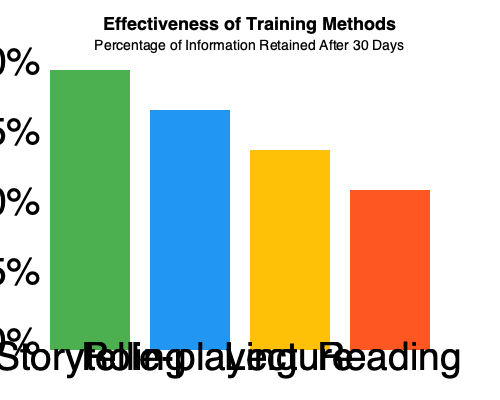Based on the bar graph comparing the effectiveness of various training methods, what is the difference in percentage points between the most effective and least effective methods, and which methods are they respectively? To answer this question, we need to follow these steps:

1. Identify the most effective method:
   - Storytelling has the highest bar, reaching about 90% retention.

2. Identify the least effective method:
   - Reading has the lowest bar, reaching about 45% retention.

3. Calculate the difference in percentage points:
   - Most effective (Storytelling): 90%
   - Least effective (Reading): 45%
   - Difference: 90% - 45% = 45 percentage points

4. Verify the methods:
   - Most effective: Storytelling
   - Least effective: Reading

Therefore, the difference in percentage points between the most effective method (Storytelling) and the least effective method (Reading) is 45 percentage points.
Answer: 45 percentage points; Storytelling (most) and Reading (least) 